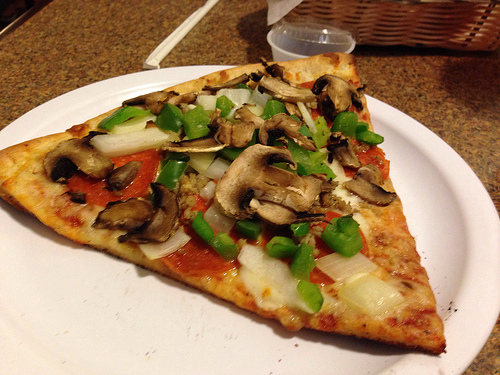Please provide the bounding box coordinate of the region this sentence describes: A plastic container with a lid. The coordinates that best describe the region containing a plastic container with a lid are [0.51, 0.14, 0.75, 0.28]. 